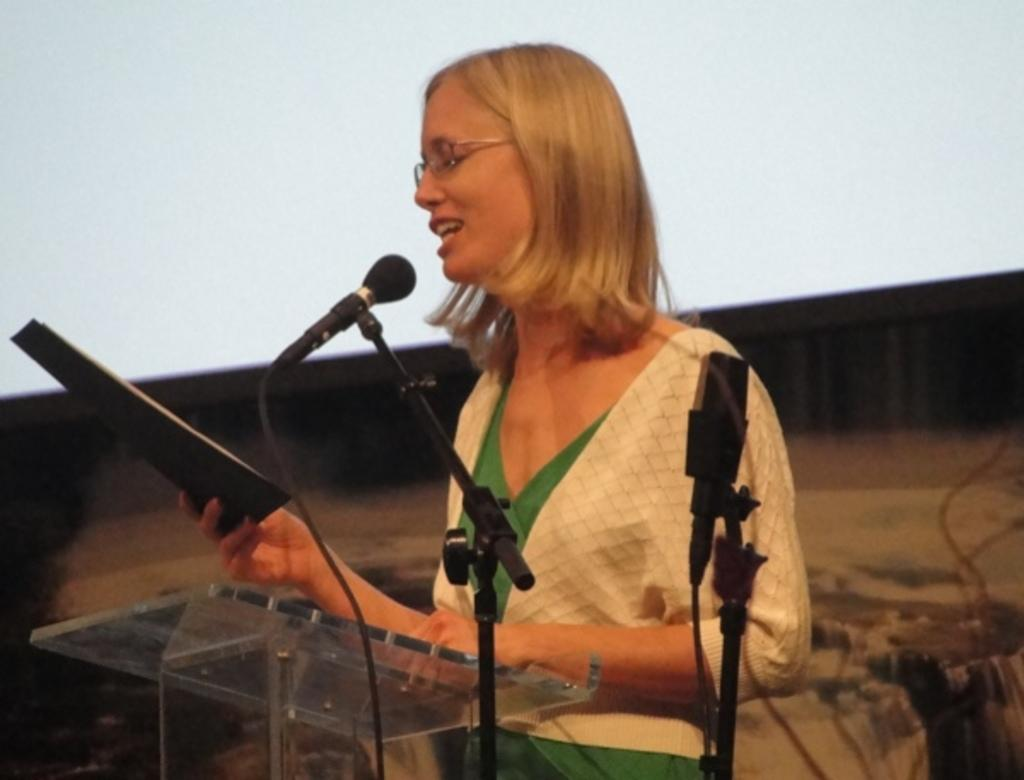Who is the main subject in the image? There is a woman in the image. What is the woman doing in the image? The woman is speaking into a microphone. What else is the woman holding in the image? The woman is holding a book. What type of appliance is the woman using to flip pancakes in the image? There is no appliance or pancakes present in the image. Can you see any feathers on the woman's clothing in the image? There is no mention of feathers or any specific clothing details in the image. 